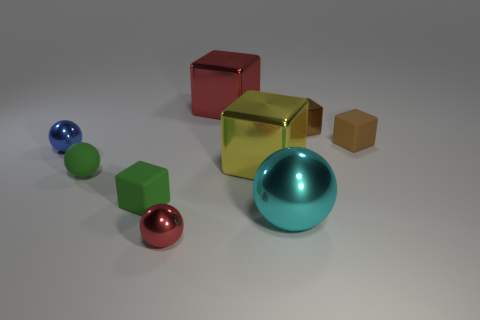There is a big metal object to the right of the large yellow metal block; does it have the same shape as the red object behind the small red metallic sphere?
Ensure brevity in your answer.  No. Is there anything else that is the same color as the small metallic block?
Your answer should be compact. Yes. What shape is the tiny green object that is the same material as the green cube?
Ensure brevity in your answer.  Sphere. There is a small cube that is both in front of the small brown metal thing and right of the tiny red thing; what material is it?
Give a very brief answer. Rubber. Is there any other thing that has the same size as the blue ball?
Provide a succinct answer. Yes. Do the big metal sphere and the small matte sphere have the same color?
Make the answer very short. No. The thing that is the same color as the small matte sphere is what shape?
Keep it short and to the point. Cube. How many green rubber objects have the same shape as the large cyan thing?
Provide a succinct answer. 1. What is the size of the brown object that is made of the same material as the large cyan object?
Provide a short and direct response. Small. Is the cyan thing the same size as the brown shiny object?
Provide a succinct answer. No. 